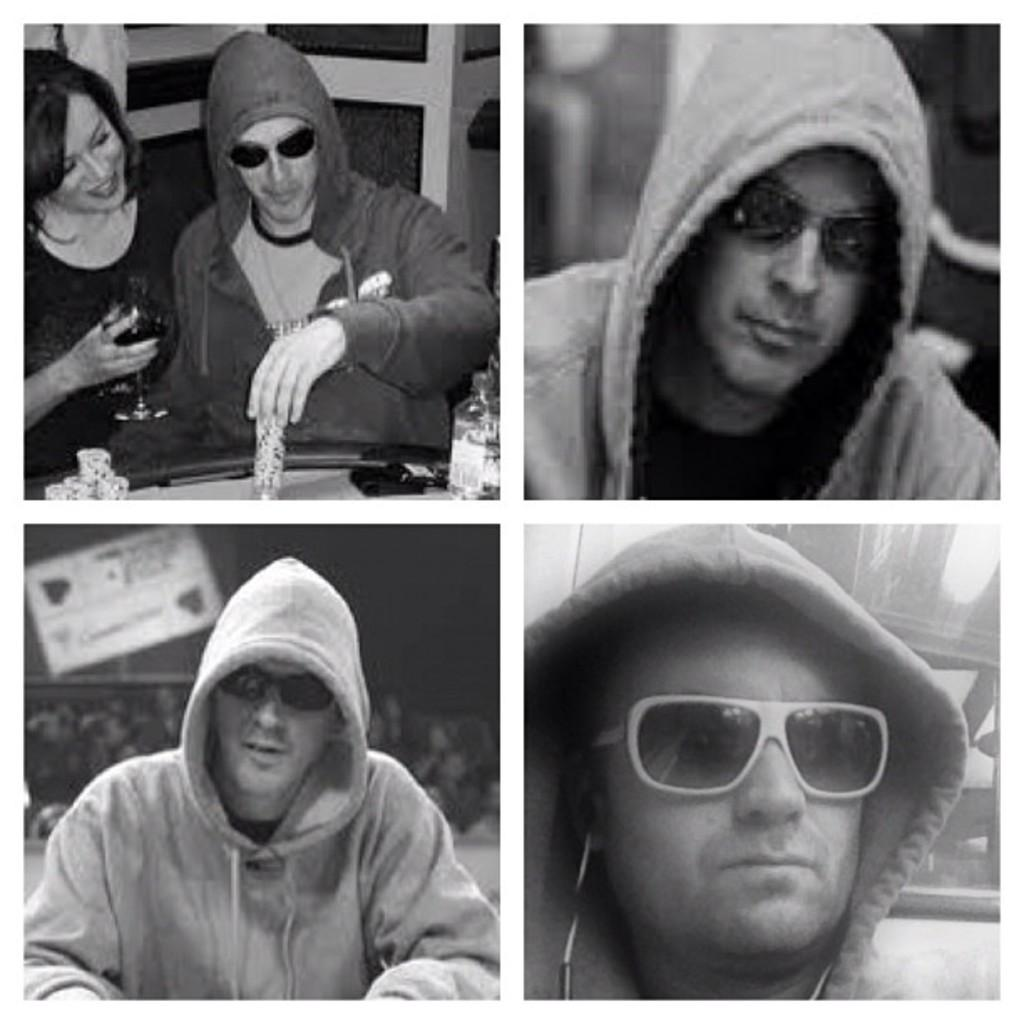What type of image is being described? The image is a collage. Are there any living beings in the image? Yes, there are people in the image. What is one person doing in the image? One person is holding a glass. What is the color scheme of the image? The image is in black and white. What type of bead is being used to make the stew in the image? A: There is no bead or stew present in the image. Is there an island visible in the image? No, there is no island visible in the image. 